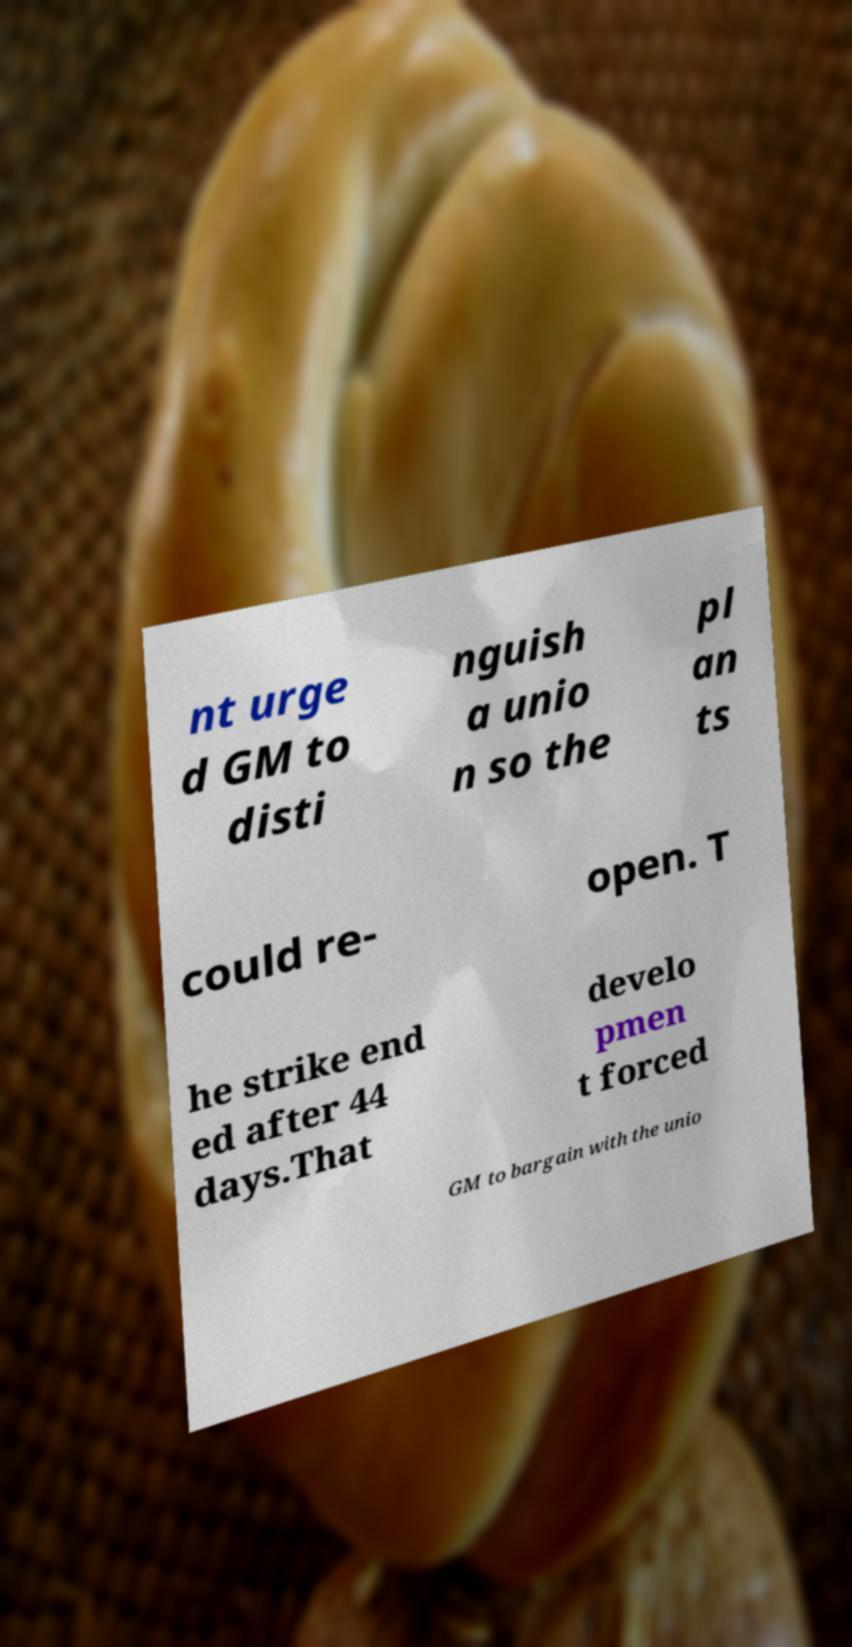For documentation purposes, I need the text within this image transcribed. Could you provide that? nt urge d GM to disti nguish a unio n so the pl an ts could re- open. T he strike end ed after 44 days.That develo pmen t forced GM to bargain with the unio 